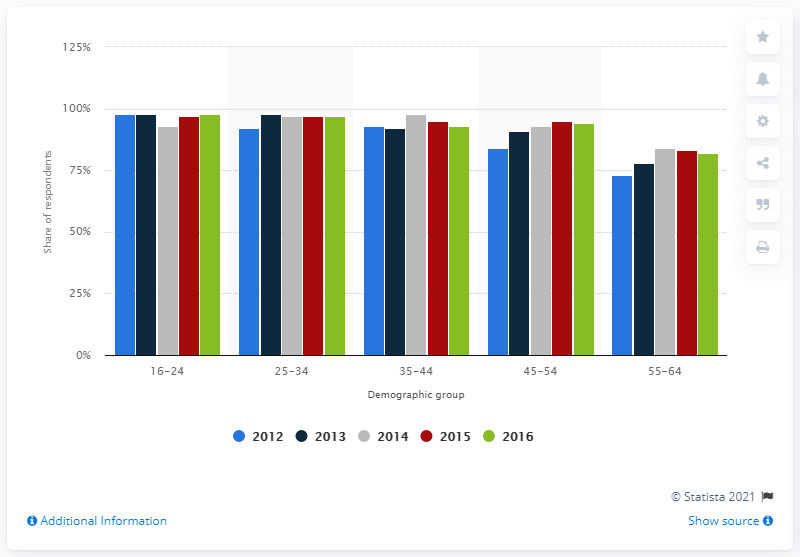What additional information might be useful to fully understand the data in this chart? To fully comprehend this data, it would be useful to know the total population size of each demographic group, as it would provide context for the percentages. Additionally, information on how the survey was conducted, such as the sample size, method of data collection, and the exact questions asked, would also be beneficial for interpreting the results accurately. 